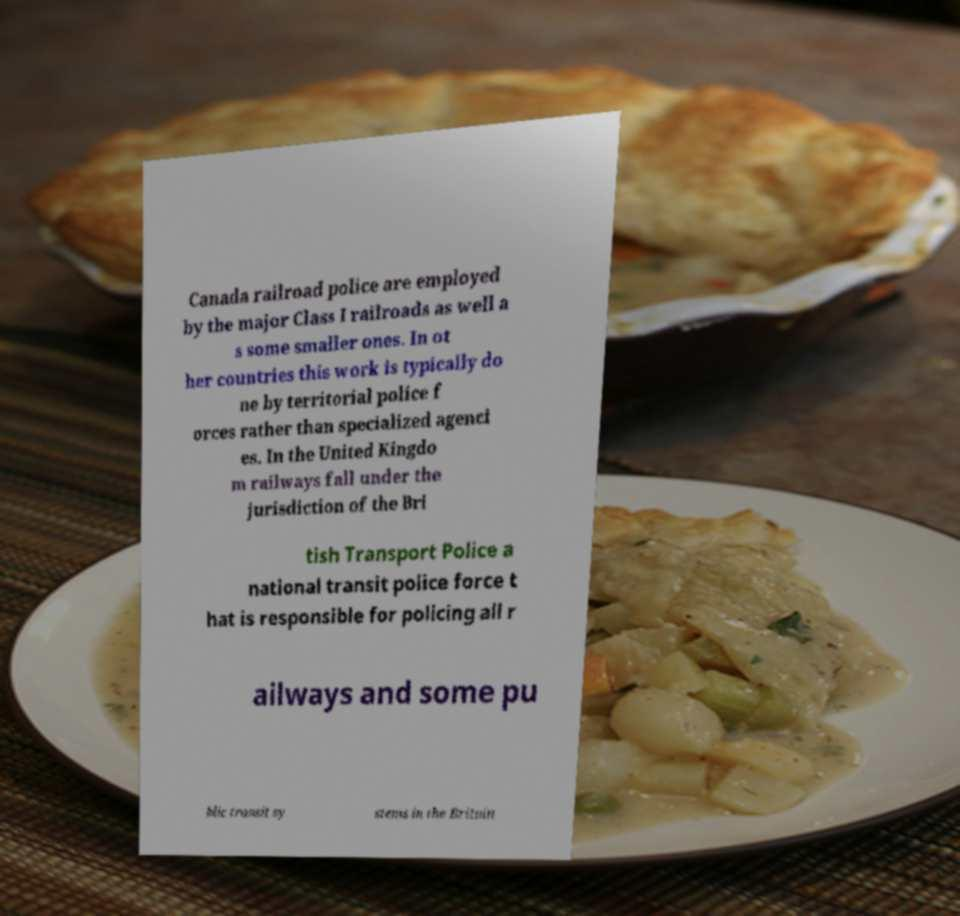Please read and relay the text visible in this image. What does it say? Canada railroad police are employed by the major Class I railroads as well a s some smaller ones. In ot her countries this work is typically do ne by territorial police f orces rather than specialized agenci es. In the United Kingdo m railways fall under the jurisdiction of the Bri tish Transport Police a national transit police force t hat is responsible for policing all r ailways and some pu blic transit sy stems in the Britain 